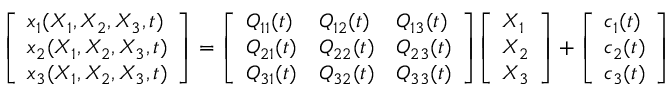<formula> <loc_0><loc_0><loc_500><loc_500>{ \left [ \begin{array} { l } { x _ { 1 } ( X _ { 1 } , X _ { 2 } , X _ { 3 } , t ) } \\ { x _ { 2 } ( X _ { 1 } , X _ { 2 } , X _ { 3 } , t ) } \\ { x _ { 3 } ( X _ { 1 } , X _ { 2 } , X _ { 3 } , t ) } \end{array} \right ] } = { \left [ \begin{array} { l l l } { Q _ { 1 1 } ( t ) } & { Q _ { 1 2 } ( t ) } & { Q _ { 1 3 } ( t ) } \\ { Q _ { 2 1 } ( t ) } & { Q _ { 2 2 } ( t ) } & { Q _ { 2 3 } ( t ) } \\ { Q _ { 3 1 } ( t ) } & { Q _ { 3 2 } ( t ) } & { Q _ { 3 3 } ( t ) } \end{array} \right ] } { \left [ \begin{array} { l } { X _ { 1 } } \\ { X _ { 2 } } \\ { X _ { 3 } } \end{array} \right ] } + { \left [ \begin{array} { l } { c _ { 1 } ( t ) } \\ { c _ { 2 } ( t ) } \\ { c _ { 3 } ( t ) } \end{array} \right ] }</formula> 